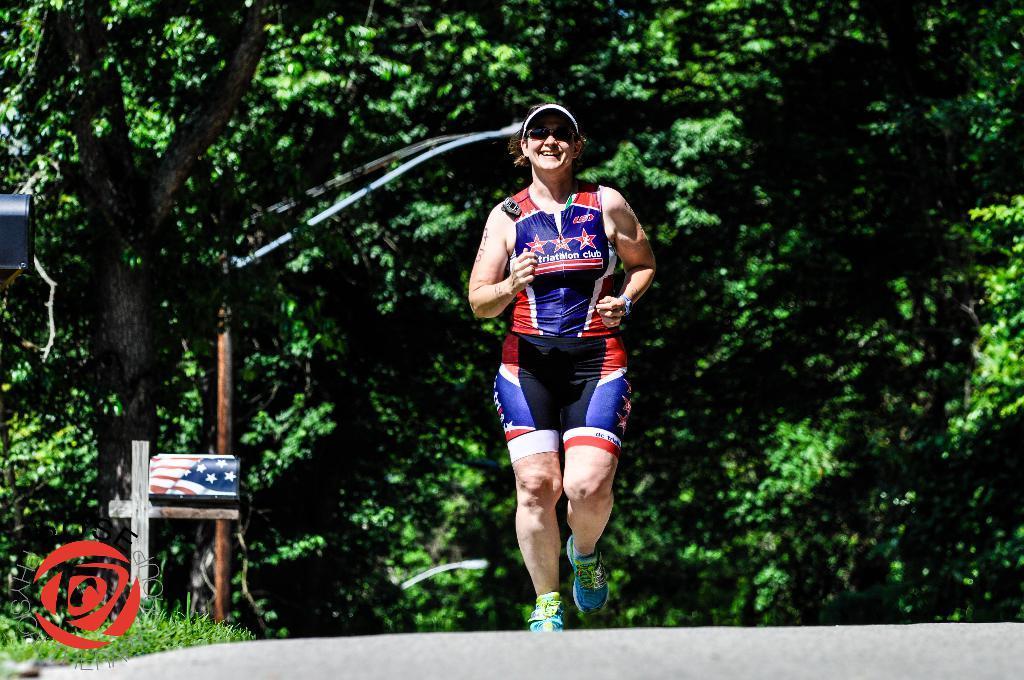Can you describe this image briefly? In this picture we can see a person running on the road. On the left side of the image, there is a street light and some objects. Behind the person, there are trees. In the bottom left corner of the image, there is a watermark. 